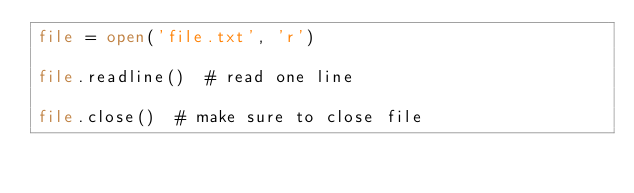Convert code to text. <code><loc_0><loc_0><loc_500><loc_500><_Python_>file = open('file.txt', 'r')

file.readline()  # read one line

file.close()  # make sure to close file</code> 